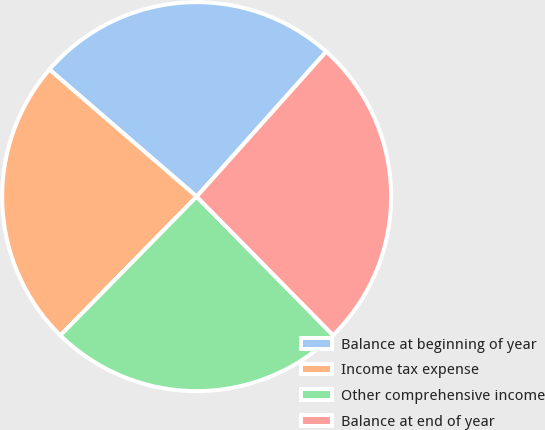Convert chart to OTSL. <chart><loc_0><loc_0><loc_500><loc_500><pie_chart><fcel>Balance at beginning of year<fcel>Income tax expense<fcel>Other comprehensive income<fcel>Balance at end of year<nl><fcel>25.27%<fcel>23.98%<fcel>24.73%<fcel>26.02%<nl></chart> 